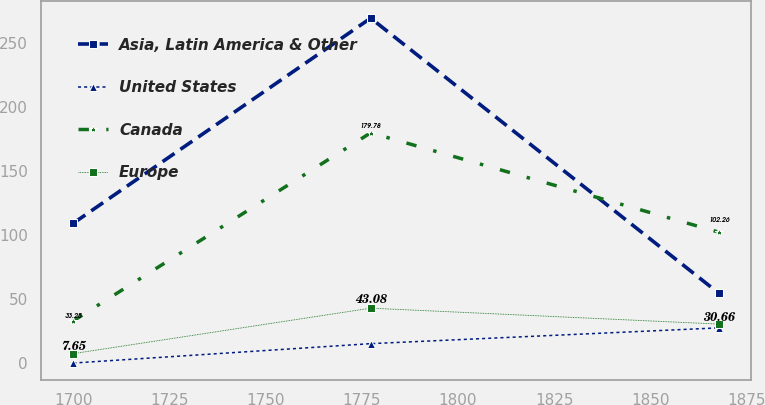<chart> <loc_0><loc_0><loc_500><loc_500><line_chart><ecel><fcel>Asia, Latin America & Other<fcel>United States<fcel>Canada<fcel>Europe<nl><fcel>1700.08<fcel>109.35<fcel>0.3<fcel>33.25<fcel>7.65<nl><fcel>1777.31<fcel>269.16<fcel>15.41<fcel>179.78<fcel>43.08<nl><fcel>1867.81<fcel>54.55<fcel>27.73<fcel>102.26<fcel>30.66<nl></chart> 